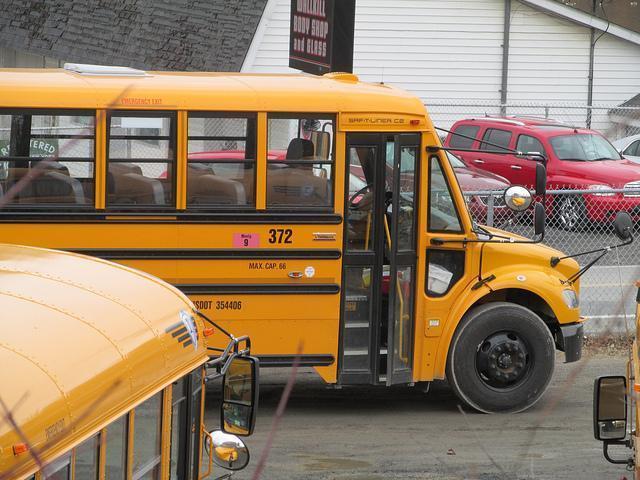How many cars can be seen?
Give a very brief answer. 2. How many buses are in the picture?
Give a very brief answer. 2. How many ties are there?
Give a very brief answer. 0. 